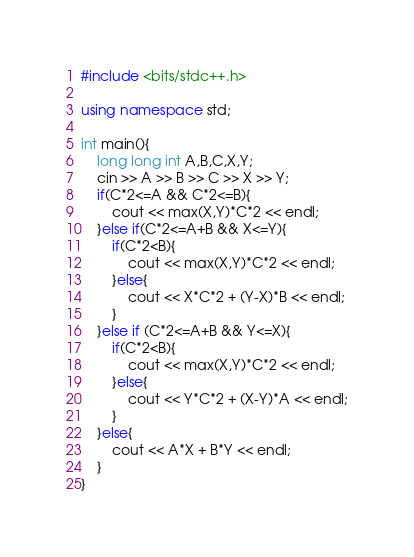<code> <loc_0><loc_0><loc_500><loc_500><_C++_>#include <bits/stdc++.h>

using namespace std;

int main(){
    long long int A,B,C,X,Y;
    cin >> A >> B >> C >> X >> Y;
    if(C*2<=A && C*2<=B){
        cout << max(X,Y)*C*2 << endl;
    }else if(C*2<=A+B && X<=Y){
        if(C*2<B){
            cout << max(X,Y)*C*2 << endl;
        }else{
            cout << X*C*2 + (Y-X)*B << endl;
        }
    }else if (C*2<=A+B && Y<=X){
        if(C*2<B){
            cout << max(X,Y)*C*2 << endl;
        }else{
            cout << Y*C*2 + (X-Y)*A << endl;
        }
    }else{
        cout << A*X + B*Y << endl;
    }
}</code> 